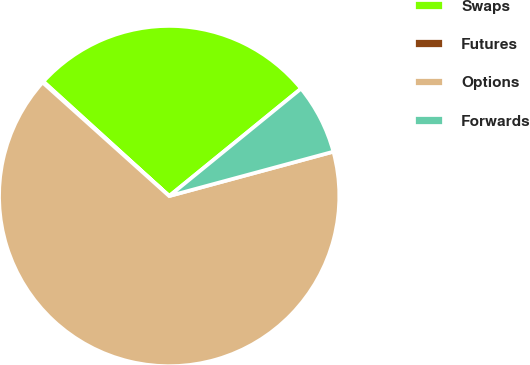Convert chart. <chart><loc_0><loc_0><loc_500><loc_500><pie_chart><fcel>Swaps<fcel>Futures<fcel>Options<fcel>Forwards<nl><fcel>27.37%<fcel>0.11%<fcel>65.84%<fcel>6.68%<nl></chart> 